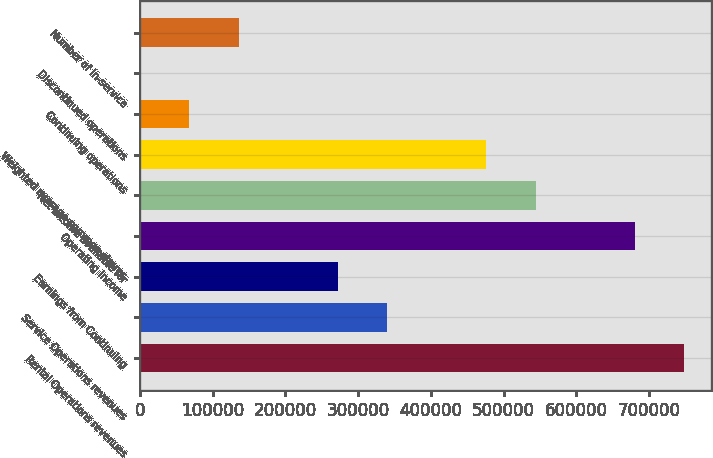Convert chart. <chart><loc_0><loc_0><loc_500><loc_500><bar_chart><fcel>Rental Operations revenues<fcel>Service Operations revenues<fcel>Earnings from Continuing<fcel>Operating income<fcel>Net income available for<fcel>Weighted average common shares<fcel>Continuing operations<fcel>Discontinued operations<fcel>Number of in-service<nl><fcel>748008<fcel>340004<fcel>272003<fcel>680007<fcel>544006<fcel>476005<fcel>68000.7<fcel>0.05<fcel>136001<nl></chart> 